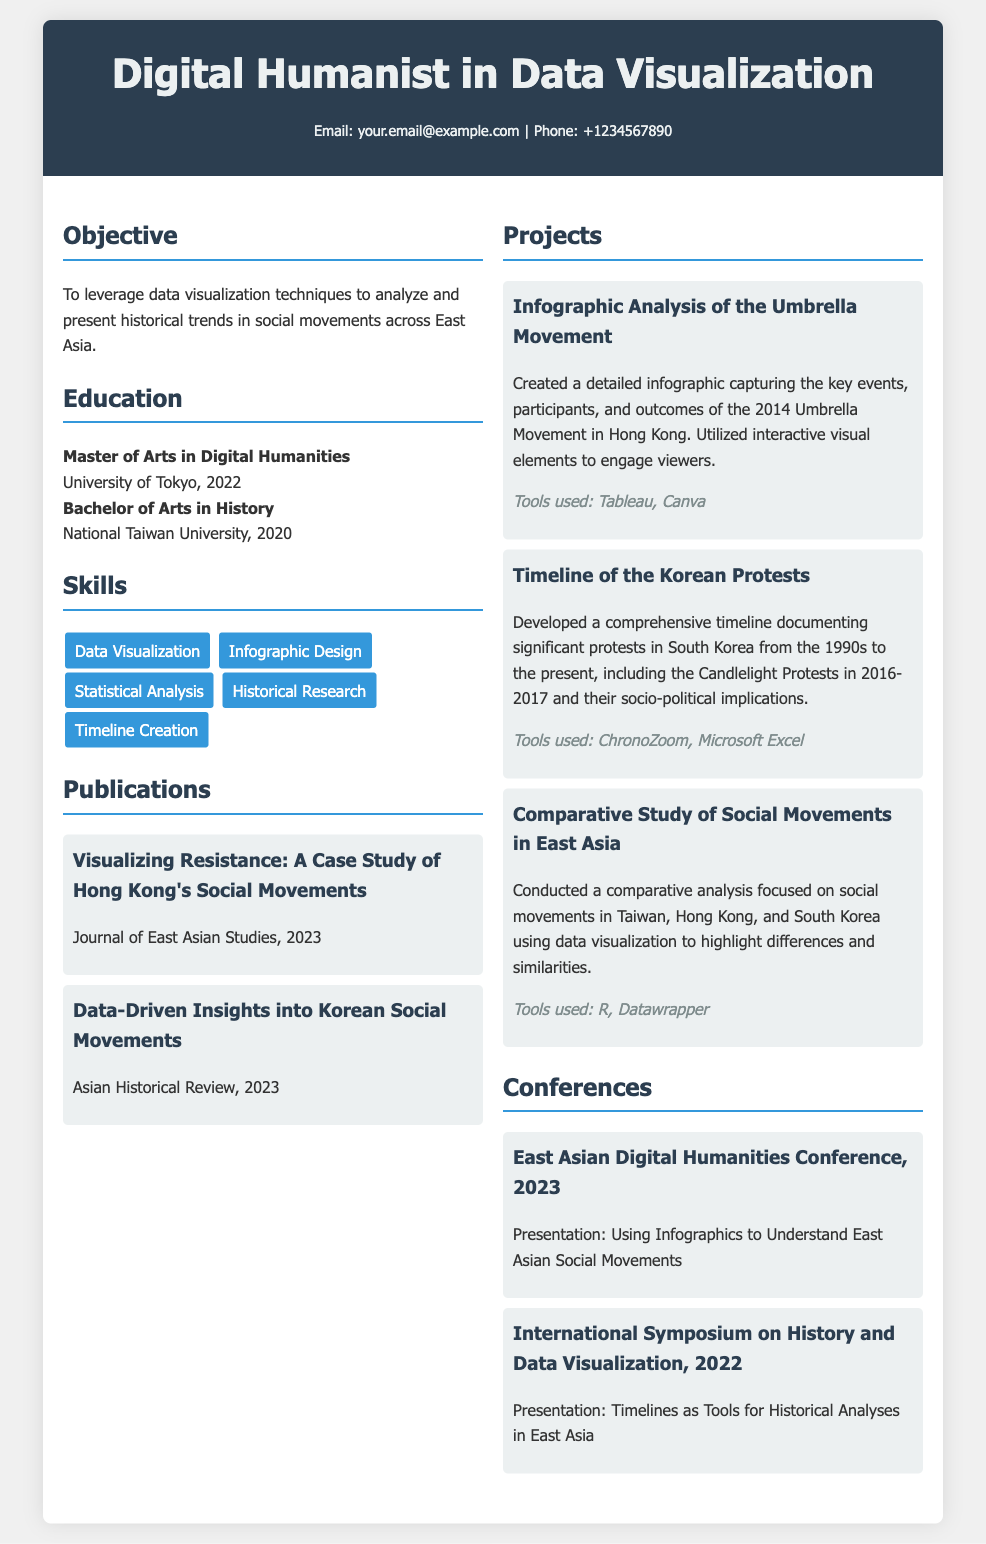What degree did the individual obtain at the University of Tokyo? The individual obtained a Master of Arts in Digital Humanities at the University of Tokyo in 2022.
Answer: Master of Arts in Digital Humanities How many publications are listed in the resume? There are two publications mentioned in the resume.
Answer: 2 What is the title of the project focusing on the Umbrella Movement? The title of the project focusing on the Umbrella Movement is "Infographic Analysis of the Umbrella Movement."
Answer: Infographic Analysis of the Umbrella Movement Which tool was used to develop the timeline of the Korean protests? The tool used to develop the timeline of the Korean protests is ChronoZoom.
Answer: ChronoZoom What year was the East Asian Digital Humanities Conference held? The East Asian Digital Humanities Conference was held in 2023.
Answer: 2023 What is the main focus of the individual's objective? The main focus of the individual's objective is to analyze and present historical trends in social movements across East Asia using data visualization techniques.
Answer: Historical trends in social movements Which publication discusses Korean social movements? The publication that discusses Korean social movements is "Data-Driven Insights into Korean Social Movements."
Answer: Data-Driven Insights into Korean Social Movements What type of skills is highlighted in the resume? The skills highlighted include Data Visualization, Infographic Design, Statistical Analysis, Historical Research, and Timeline Creation.
Answer: Data Visualization, Infographic Design, Statistical Analysis, Historical Research, Timeline Creation What was the presentation topic at the International Symposium on History and Data Visualization? The presentation topic at the International Symposium on History and Data Visualization was "Timelines as Tools for Historical Analyses in East Asia."
Answer: Timelines as Tools for Historical Analyses in East Asia 